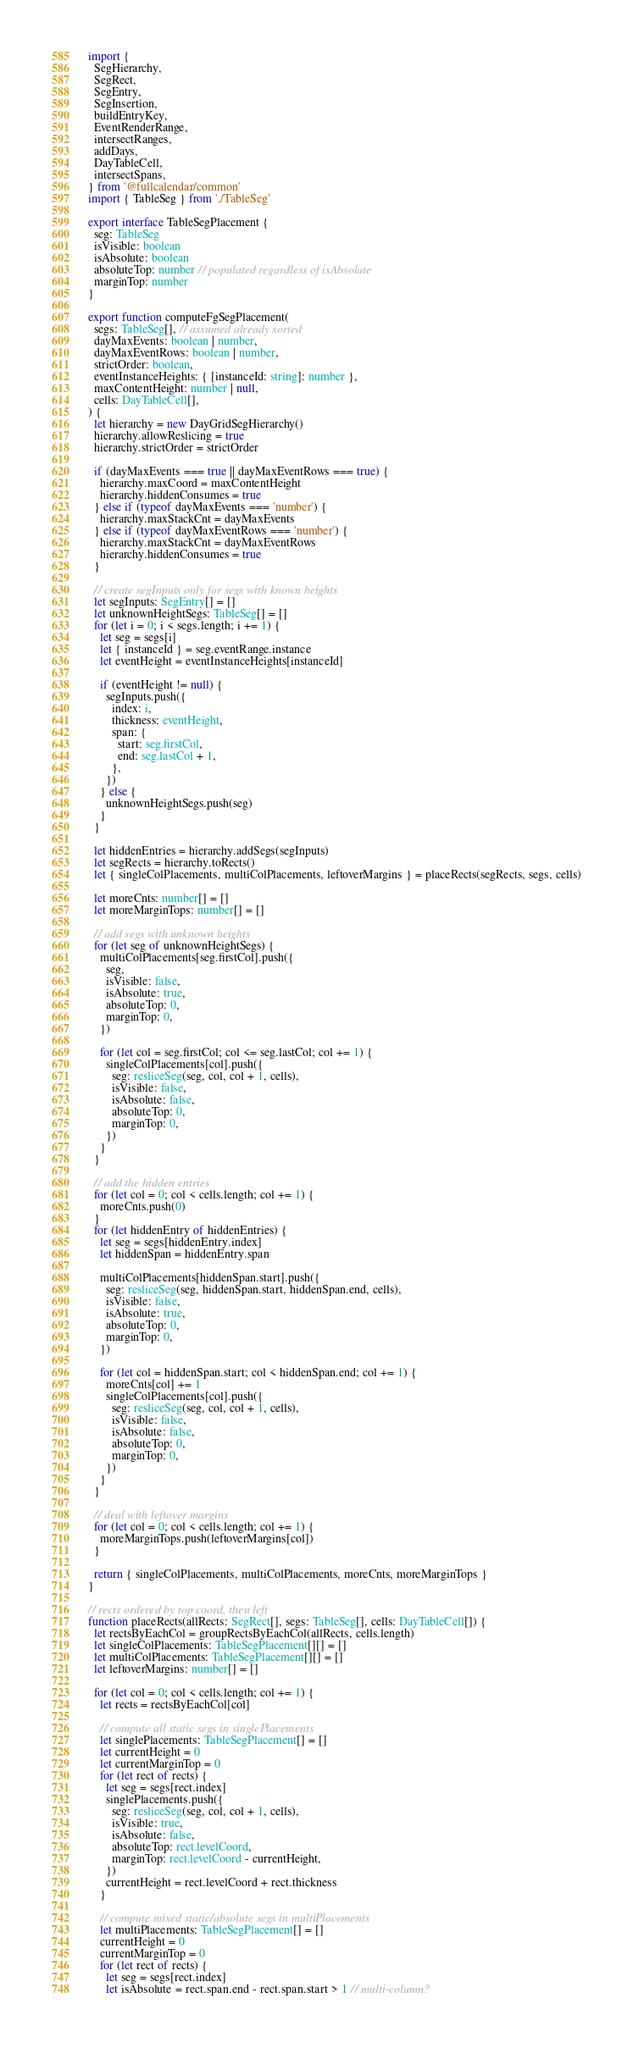<code> <loc_0><loc_0><loc_500><loc_500><_TypeScript_>import {
  SegHierarchy,
  SegRect,
  SegEntry,
  SegInsertion,
  buildEntryKey,
  EventRenderRange,
  intersectRanges,
  addDays,
  DayTableCell,
  intersectSpans,
} from '@fullcalendar/common'
import { TableSeg } from './TableSeg'

export interface TableSegPlacement {
  seg: TableSeg
  isVisible: boolean
  isAbsolute: boolean
  absoluteTop: number // populated regardless of isAbsolute
  marginTop: number
}

export function computeFgSegPlacement(
  segs: TableSeg[], // assumed already sorted
  dayMaxEvents: boolean | number,
  dayMaxEventRows: boolean | number,
  strictOrder: boolean,
  eventInstanceHeights: { [instanceId: string]: number },
  maxContentHeight: number | null,
  cells: DayTableCell[],
) {
  let hierarchy = new DayGridSegHierarchy()
  hierarchy.allowReslicing = true
  hierarchy.strictOrder = strictOrder

  if (dayMaxEvents === true || dayMaxEventRows === true) {
    hierarchy.maxCoord = maxContentHeight
    hierarchy.hiddenConsumes = true
  } else if (typeof dayMaxEvents === 'number') {
    hierarchy.maxStackCnt = dayMaxEvents
  } else if (typeof dayMaxEventRows === 'number') {
    hierarchy.maxStackCnt = dayMaxEventRows
    hierarchy.hiddenConsumes = true
  }

  // create segInputs only for segs with known heights
  let segInputs: SegEntry[] = []
  let unknownHeightSegs: TableSeg[] = []
  for (let i = 0; i < segs.length; i += 1) {
    let seg = segs[i]
    let { instanceId } = seg.eventRange.instance
    let eventHeight = eventInstanceHeights[instanceId]

    if (eventHeight != null) {
      segInputs.push({
        index: i,
        thickness: eventHeight,
        span: {
          start: seg.firstCol,
          end: seg.lastCol + 1,
        },
      })
    } else {
      unknownHeightSegs.push(seg)
    }
  }

  let hiddenEntries = hierarchy.addSegs(segInputs)
  let segRects = hierarchy.toRects()
  let { singleColPlacements, multiColPlacements, leftoverMargins } = placeRects(segRects, segs, cells)

  let moreCnts: number[] = []
  let moreMarginTops: number[] = []

  // add segs with unknown heights
  for (let seg of unknownHeightSegs) {
    multiColPlacements[seg.firstCol].push({
      seg,
      isVisible: false,
      isAbsolute: true,
      absoluteTop: 0,
      marginTop: 0,
    })

    for (let col = seg.firstCol; col <= seg.lastCol; col += 1) {
      singleColPlacements[col].push({
        seg: resliceSeg(seg, col, col + 1, cells),
        isVisible: false,
        isAbsolute: false,
        absoluteTop: 0,
        marginTop: 0,
      })
    }
  }

  // add the hidden entries
  for (let col = 0; col < cells.length; col += 1) {
    moreCnts.push(0)
  }
  for (let hiddenEntry of hiddenEntries) {
    let seg = segs[hiddenEntry.index]
    let hiddenSpan = hiddenEntry.span

    multiColPlacements[hiddenSpan.start].push({
      seg: resliceSeg(seg, hiddenSpan.start, hiddenSpan.end, cells),
      isVisible: false,
      isAbsolute: true,
      absoluteTop: 0,
      marginTop: 0,
    })

    for (let col = hiddenSpan.start; col < hiddenSpan.end; col += 1) {
      moreCnts[col] += 1
      singleColPlacements[col].push({
        seg: resliceSeg(seg, col, col + 1, cells),
        isVisible: false,
        isAbsolute: false,
        absoluteTop: 0,
        marginTop: 0,
      })
    }
  }

  // deal with leftover margins
  for (let col = 0; col < cells.length; col += 1) {
    moreMarginTops.push(leftoverMargins[col])
  }

  return { singleColPlacements, multiColPlacements, moreCnts, moreMarginTops }
}

// rects ordered by top coord, then left
function placeRects(allRects: SegRect[], segs: TableSeg[], cells: DayTableCell[]) {
  let rectsByEachCol = groupRectsByEachCol(allRects, cells.length)
  let singleColPlacements: TableSegPlacement[][] = []
  let multiColPlacements: TableSegPlacement[][] = []
  let leftoverMargins: number[] = []

  for (let col = 0; col < cells.length; col += 1) {
    let rects = rectsByEachCol[col]

    // compute all static segs in singlePlacements
    let singlePlacements: TableSegPlacement[] = []
    let currentHeight = 0
    let currentMarginTop = 0
    for (let rect of rects) {
      let seg = segs[rect.index]
      singlePlacements.push({
        seg: resliceSeg(seg, col, col + 1, cells),
        isVisible: true,
        isAbsolute: false,
        absoluteTop: rect.levelCoord,
        marginTop: rect.levelCoord - currentHeight,
      })
      currentHeight = rect.levelCoord + rect.thickness
    }

    // compute mixed static/absolute segs in multiPlacements
    let multiPlacements: TableSegPlacement[] = []
    currentHeight = 0
    currentMarginTop = 0
    for (let rect of rects) {
      let seg = segs[rect.index]
      let isAbsolute = rect.span.end - rect.span.start > 1 // multi-column?</code> 